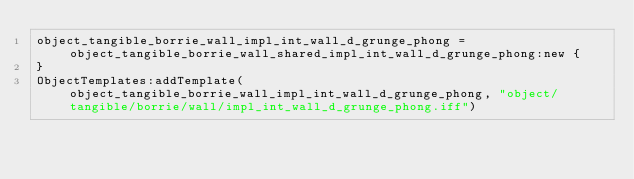Convert code to text. <code><loc_0><loc_0><loc_500><loc_500><_Lua_>object_tangible_borrie_wall_impl_int_wall_d_grunge_phong = object_tangible_borrie_wall_shared_impl_int_wall_d_grunge_phong:new {
}
ObjectTemplates:addTemplate(object_tangible_borrie_wall_impl_int_wall_d_grunge_phong, "object/tangible/borrie/wall/impl_int_wall_d_grunge_phong.iff")
</code> 